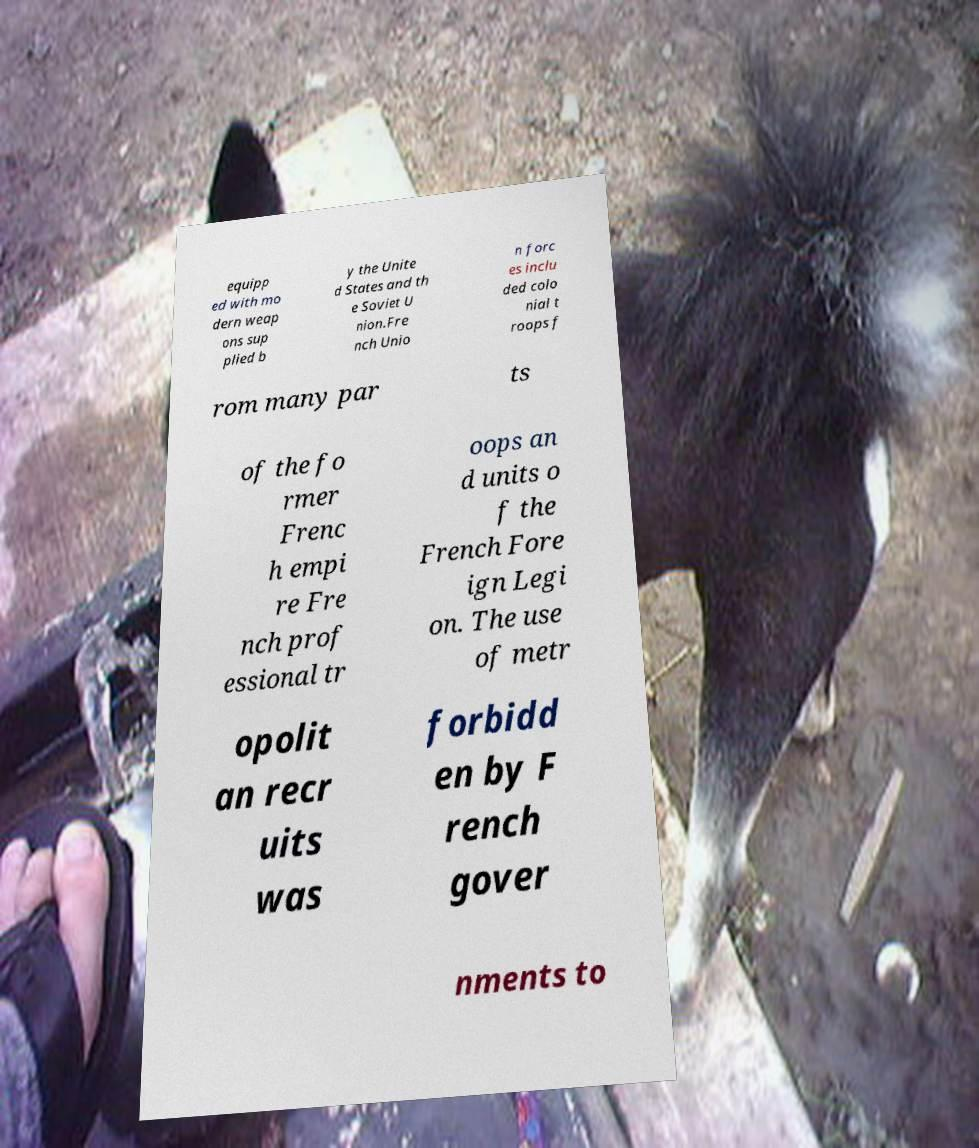Could you extract and type out the text from this image? equipp ed with mo dern weap ons sup plied b y the Unite d States and th e Soviet U nion.Fre nch Unio n forc es inclu ded colo nial t roops f rom many par ts of the fo rmer Frenc h empi re Fre nch prof essional tr oops an d units o f the French Fore ign Legi on. The use of metr opolit an recr uits was forbidd en by F rench gover nments to 